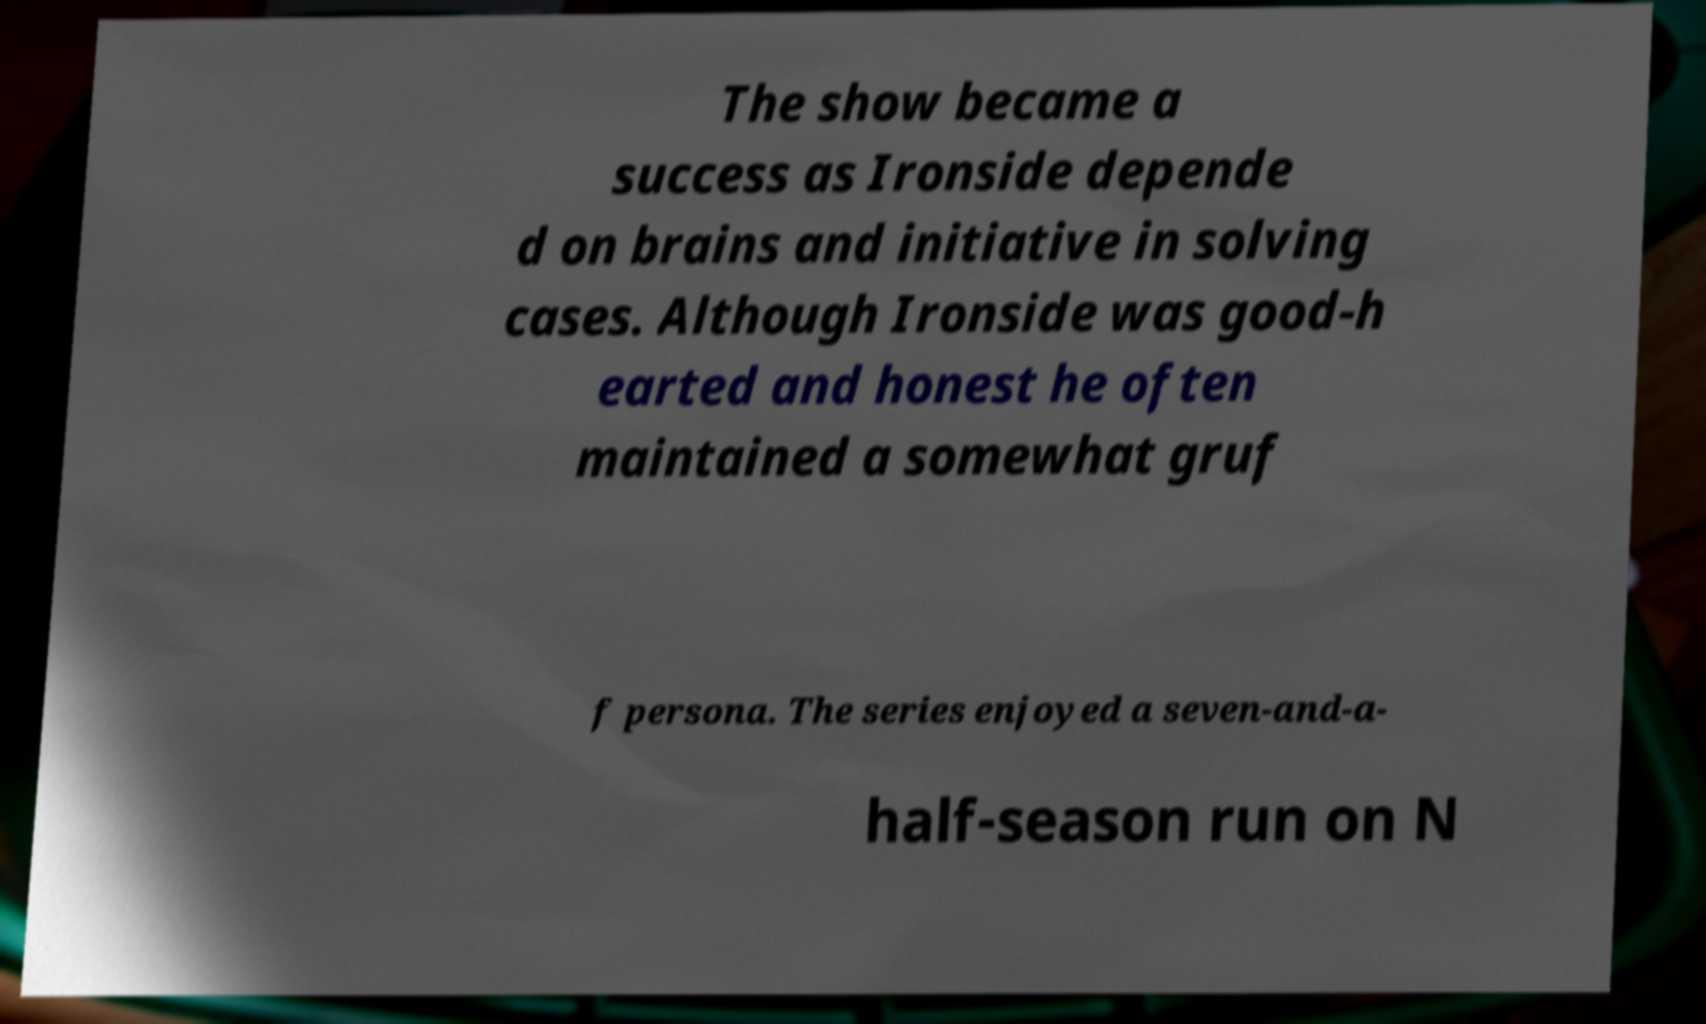Please identify and transcribe the text found in this image. The show became a success as Ironside depende d on brains and initiative in solving cases. Although Ironside was good-h earted and honest he often maintained a somewhat gruf f persona. The series enjoyed a seven-and-a- half-season run on N 